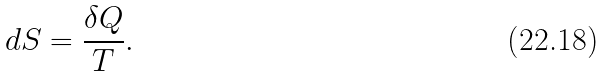<formula> <loc_0><loc_0><loc_500><loc_500>d S = \frac { \delta Q } { T } .</formula> 